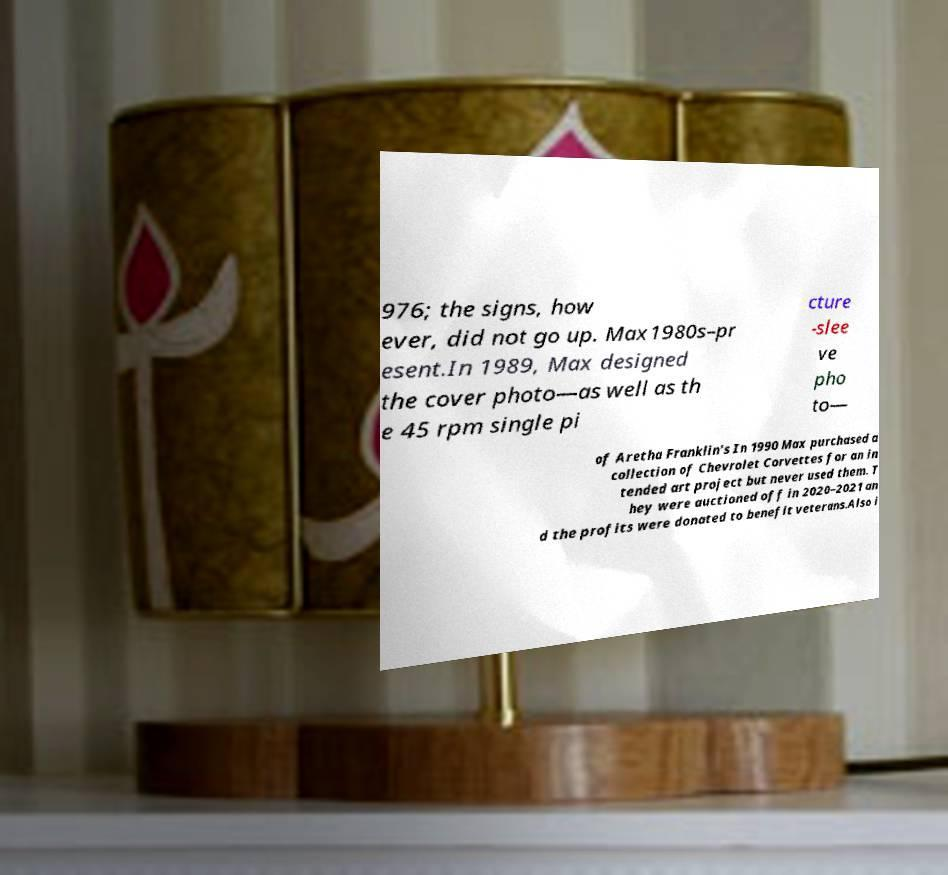I need the written content from this picture converted into text. Can you do that? 976; the signs, how ever, did not go up. Max1980s–pr esent.In 1989, Max designed the cover photo—as well as th e 45 rpm single pi cture -slee ve pho to— of Aretha Franklin's In 1990 Max purchased a collection of Chevrolet Corvettes for an in tended art project but never used them. T hey were auctioned off in 2020–2021 an d the profits were donated to benefit veterans.Also i 